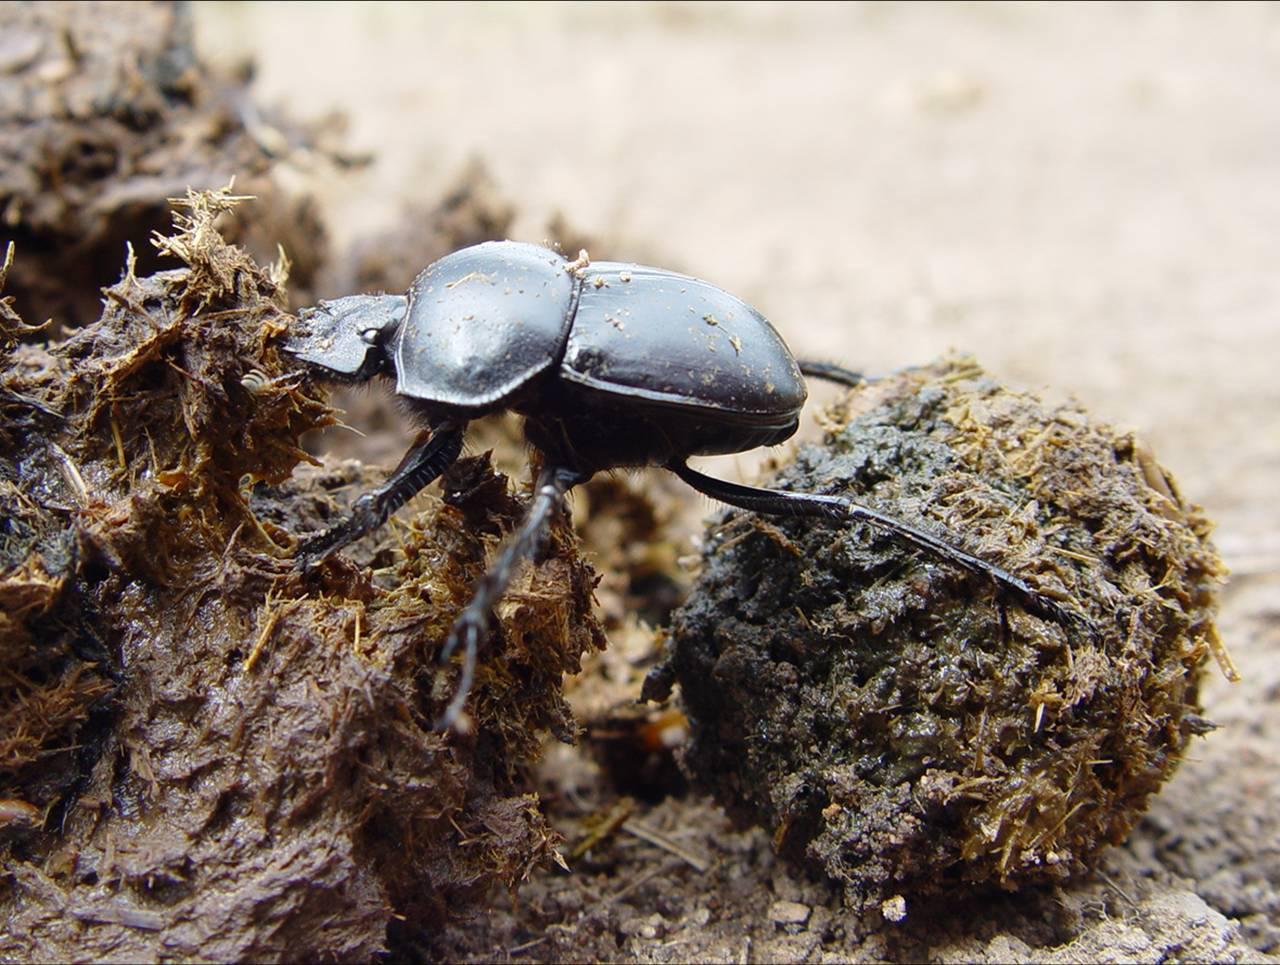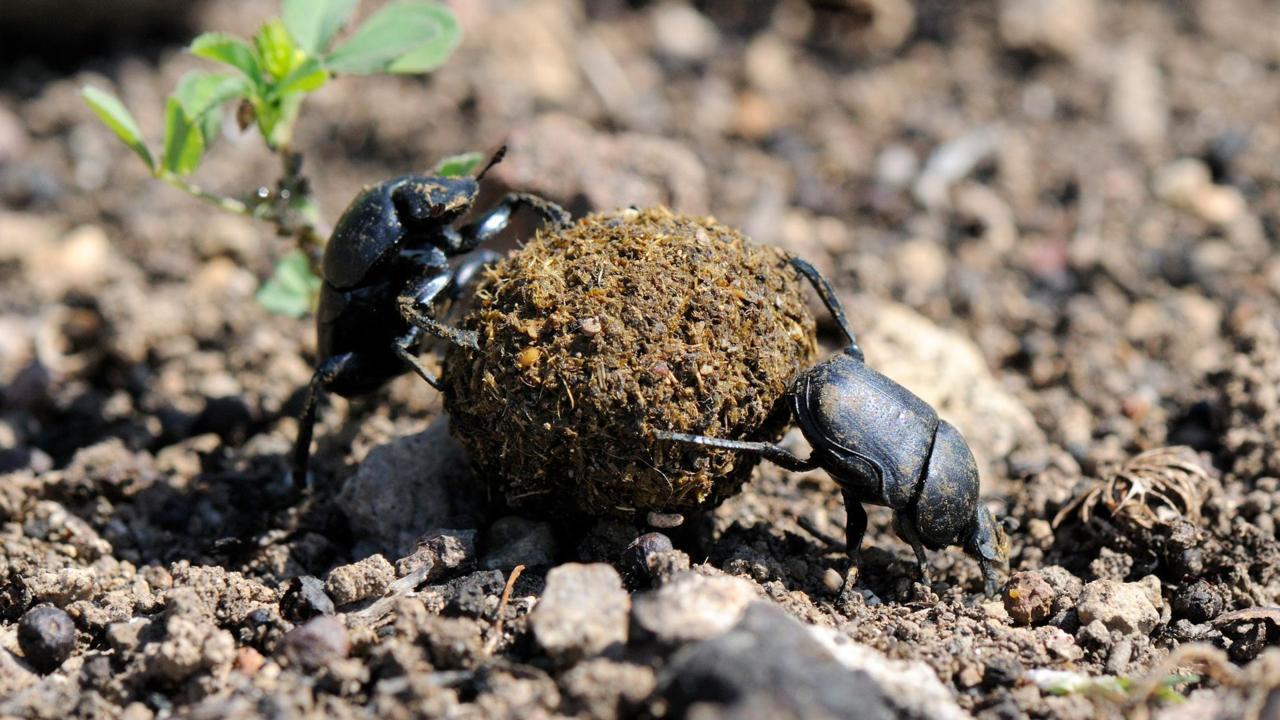The first image is the image on the left, the second image is the image on the right. Examine the images to the left and right. Is the description "An image shows exactly two black beetles by one dung ball." accurate? Answer yes or no. Yes. The first image is the image on the left, the second image is the image on the right. Considering the images on both sides, is "One of the images shows a single beetle pushing a dungball from the left." valid? Answer yes or no. Yes. 